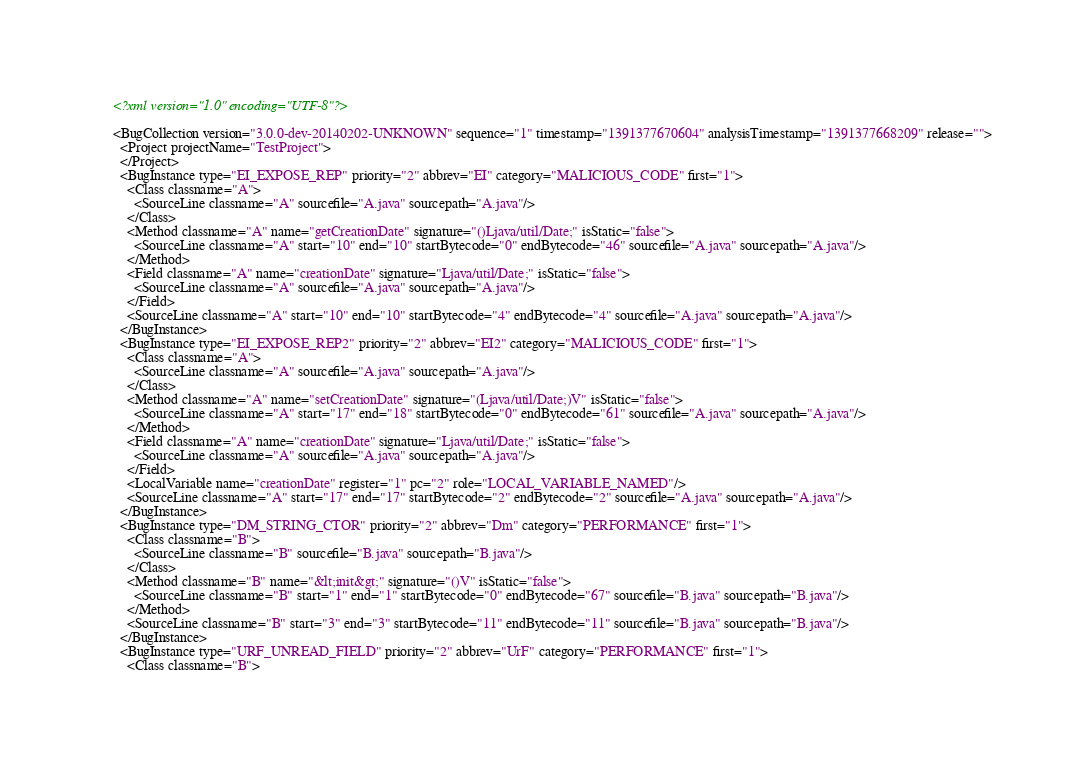<code> <loc_0><loc_0><loc_500><loc_500><_XML_><?xml version="1.0" encoding="UTF-8"?>

<BugCollection version="3.0.0-dev-20140202-UNKNOWN" sequence="1" timestamp="1391377670604" analysisTimestamp="1391377668209" release="">
  <Project projectName="TestProject">
  </Project>
  <BugInstance type="EI_EXPOSE_REP" priority="2" abbrev="EI" category="MALICIOUS_CODE" first="1">
    <Class classname="A">
      <SourceLine classname="A" sourcefile="A.java" sourcepath="A.java"/>
    </Class>
    <Method classname="A" name="getCreationDate" signature="()Ljava/util/Date;" isStatic="false">
      <SourceLine classname="A" start="10" end="10" startBytecode="0" endBytecode="46" sourcefile="A.java" sourcepath="A.java"/>
    </Method>
    <Field classname="A" name="creationDate" signature="Ljava/util/Date;" isStatic="false">
      <SourceLine classname="A" sourcefile="A.java" sourcepath="A.java"/>
    </Field>
    <SourceLine classname="A" start="10" end="10" startBytecode="4" endBytecode="4" sourcefile="A.java" sourcepath="A.java"/>
  </BugInstance>
  <BugInstance type="EI_EXPOSE_REP2" priority="2" abbrev="EI2" category="MALICIOUS_CODE" first="1">
    <Class classname="A">
      <SourceLine classname="A" sourcefile="A.java" sourcepath="A.java"/>
    </Class>
    <Method classname="A" name="setCreationDate" signature="(Ljava/util/Date;)V" isStatic="false">
      <SourceLine classname="A" start="17" end="18" startBytecode="0" endBytecode="61" sourcefile="A.java" sourcepath="A.java"/>
    </Method>
    <Field classname="A" name="creationDate" signature="Ljava/util/Date;" isStatic="false">
      <SourceLine classname="A" sourcefile="A.java" sourcepath="A.java"/>
    </Field>
    <LocalVariable name="creationDate" register="1" pc="2" role="LOCAL_VARIABLE_NAMED"/>
    <SourceLine classname="A" start="17" end="17" startBytecode="2" endBytecode="2" sourcefile="A.java" sourcepath="A.java"/>
  </BugInstance>
  <BugInstance type="DM_STRING_CTOR" priority="2" abbrev="Dm" category="PERFORMANCE" first="1">
    <Class classname="B">
      <SourceLine classname="B" sourcefile="B.java" sourcepath="B.java"/>
    </Class>
    <Method classname="B" name="&lt;init&gt;" signature="()V" isStatic="false">
      <SourceLine classname="B" start="1" end="1" startBytecode="0" endBytecode="67" sourcefile="B.java" sourcepath="B.java"/>
    </Method>
    <SourceLine classname="B" start="3" end="3" startBytecode="11" endBytecode="11" sourcefile="B.java" sourcepath="B.java"/>
  </BugInstance>
  <BugInstance type="URF_UNREAD_FIELD" priority="2" abbrev="UrF" category="PERFORMANCE" first="1">
    <Class classname="B"></code> 